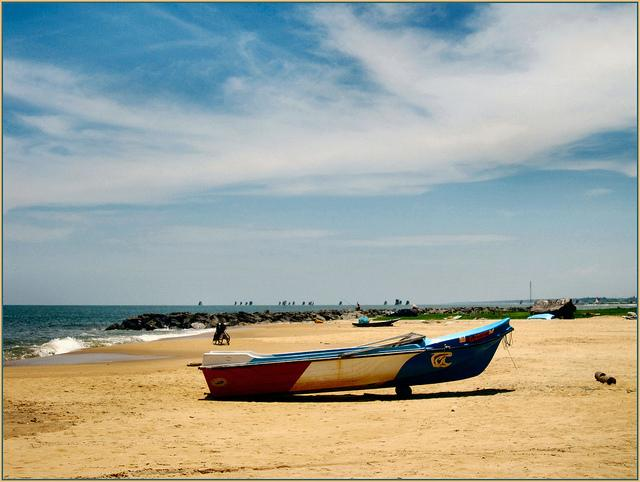Who might use the boat on the beach?

Choices:
A) lifeguards
B) senators
C) custodians
D) police lifeguards 